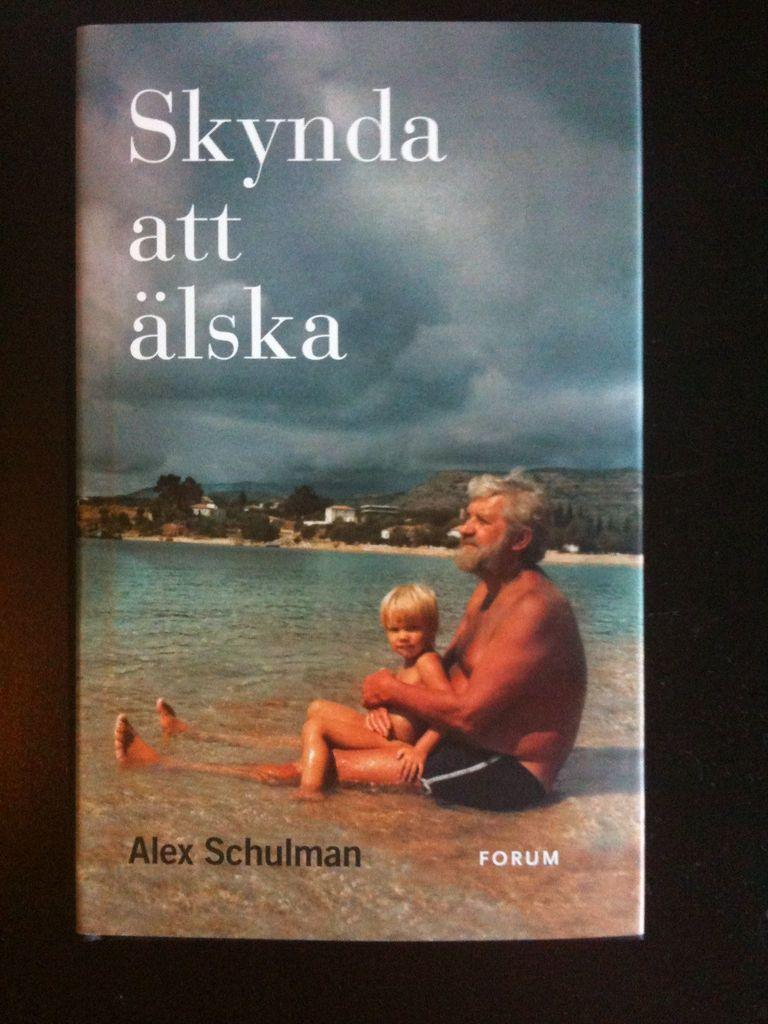<image>
Offer a succinct explanation of the picture presented. an ad of a man and son in the ocean saying "Skynda att alska" 